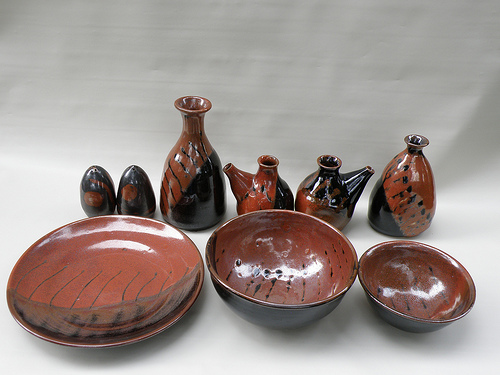What does the overall arrangement of these items depict? The arrangement of these items depicts a curated collection of handcrafted pottery. The variety of shapes and sizes, along with the cohesive color scheme of red and black, suggests that this set is meant to display the artisans' skills and the aesthetic harmony of their work. How do the colors used in these pottery items affect their appeal? The use of deep red and black enhances the visual appeal of these pottery items by providing a striking contrast. The red color captures attention with its vibrancy, while the black adds depth and sophistication. Together, they create a visually rich and dynamic composition that can complement a variety of decor styles. 